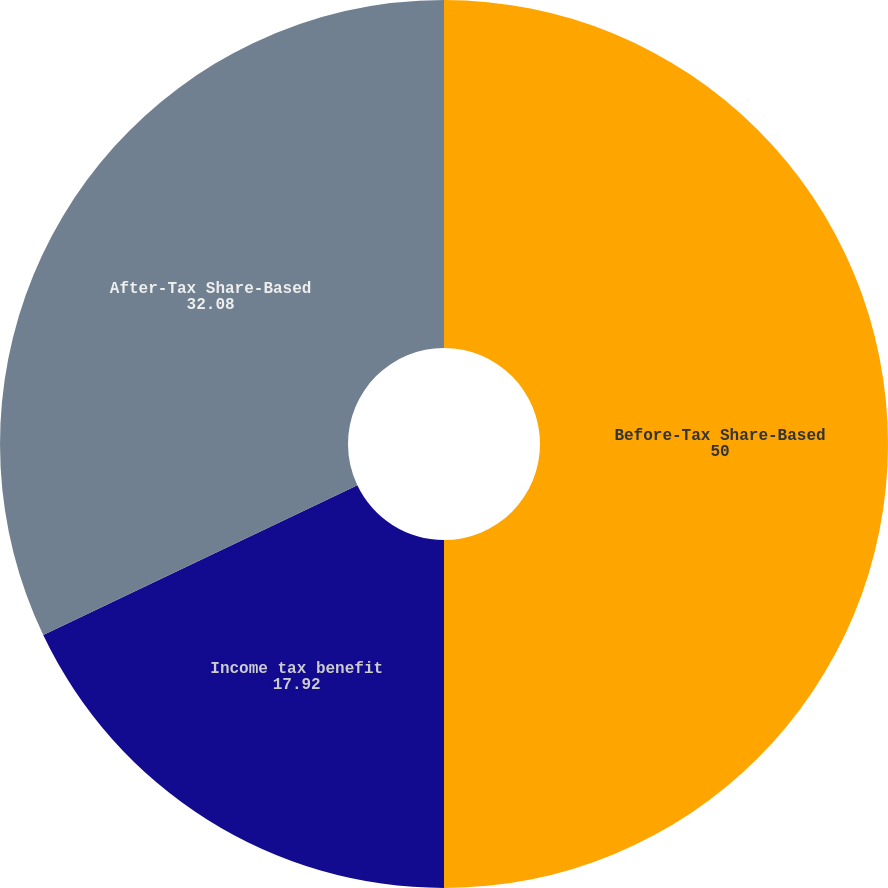Convert chart. <chart><loc_0><loc_0><loc_500><loc_500><pie_chart><fcel>Before-Tax Share-Based<fcel>Income tax benefit<fcel>After-Tax Share-Based<nl><fcel>50.0%<fcel>17.92%<fcel>32.08%<nl></chart> 